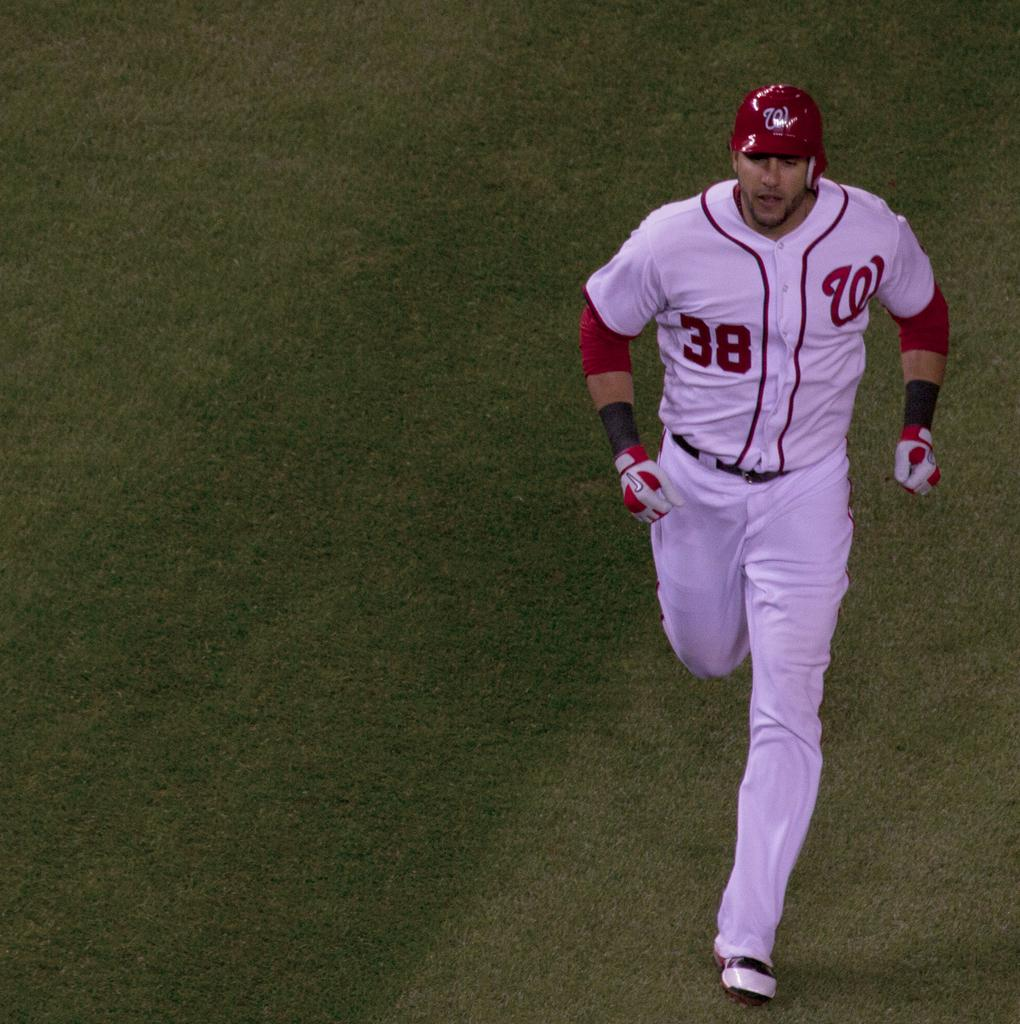<image>
Summarize the visual content of the image. A hitter in a white and red jersey wearing number 38 is running. 